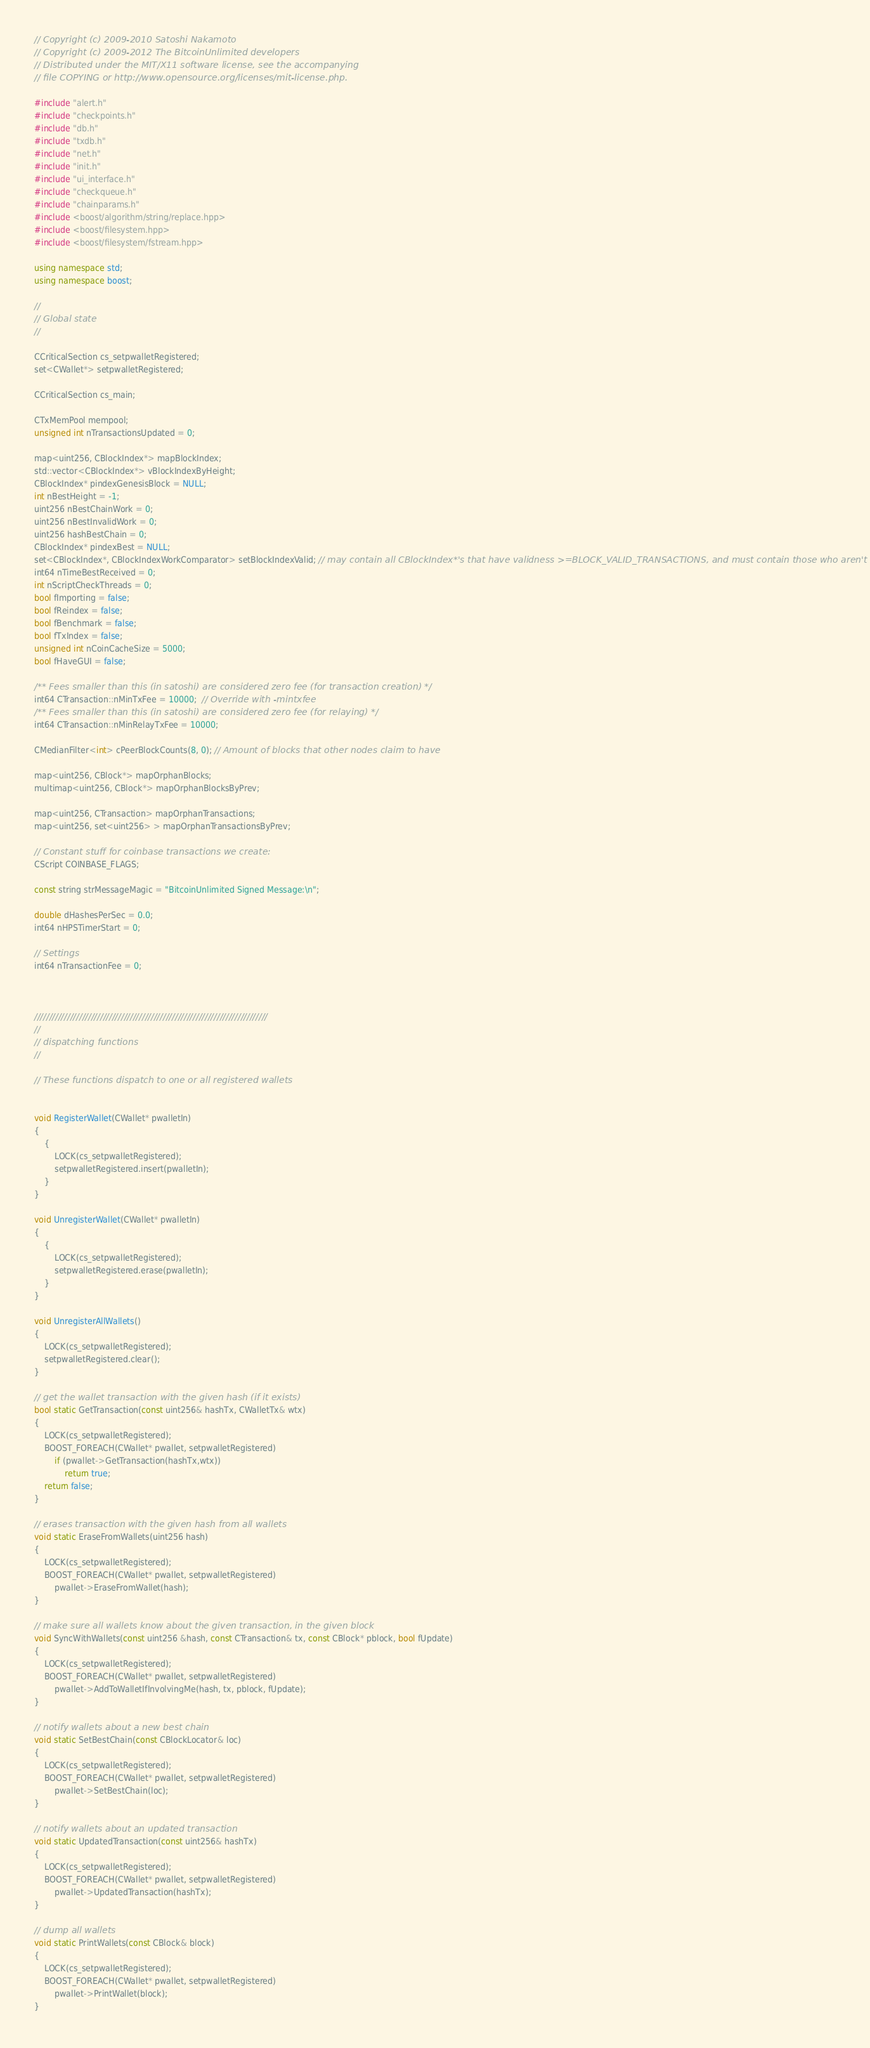Convert code to text. <code><loc_0><loc_0><loc_500><loc_500><_C++_>// Copyright (c) 2009-2010 Satoshi Nakamoto
// Copyright (c) 2009-2012 The BitcoinUnlimited developers
// Distributed under the MIT/X11 software license, see the accompanying
// file COPYING or http://www.opensource.org/licenses/mit-license.php.

#include "alert.h"
#include "checkpoints.h"
#include "db.h"
#include "txdb.h"
#include "net.h"
#include "init.h"
#include "ui_interface.h"
#include "checkqueue.h"
#include "chainparams.h"
#include <boost/algorithm/string/replace.hpp>
#include <boost/filesystem.hpp>
#include <boost/filesystem/fstream.hpp>

using namespace std;
using namespace boost;

//
// Global state
//

CCriticalSection cs_setpwalletRegistered;
set<CWallet*> setpwalletRegistered;

CCriticalSection cs_main;

CTxMemPool mempool;
unsigned int nTransactionsUpdated = 0;

map<uint256, CBlockIndex*> mapBlockIndex;
std::vector<CBlockIndex*> vBlockIndexByHeight;
CBlockIndex* pindexGenesisBlock = NULL;
int nBestHeight = -1;
uint256 nBestChainWork = 0;
uint256 nBestInvalidWork = 0;
uint256 hashBestChain = 0;
CBlockIndex* pindexBest = NULL;
set<CBlockIndex*, CBlockIndexWorkComparator> setBlockIndexValid; // may contain all CBlockIndex*'s that have validness >=BLOCK_VALID_TRANSACTIONS, and must contain those who aren't failed
int64 nTimeBestReceived = 0;
int nScriptCheckThreads = 0;
bool fImporting = false;
bool fReindex = false;
bool fBenchmark = false;
bool fTxIndex = false;
unsigned int nCoinCacheSize = 5000;
bool fHaveGUI = false;

/** Fees smaller than this (in satoshi) are considered zero fee (for transaction creation) */
int64 CTransaction::nMinTxFee = 10000;  // Override with -mintxfee
/** Fees smaller than this (in satoshi) are considered zero fee (for relaying) */
int64 CTransaction::nMinRelayTxFee = 10000;

CMedianFilter<int> cPeerBlockCounts(8, 0); // Amount of blocks that other nodes claim to have

map<uint256, CBlock*> mapOrphanBlocks;
multimap<uint256, CBlock*> mapOrphanBlocksByPrev;

map<uint256, CTransaction> mapOrphanTransactions;
map<uint256, set<uint256> > mapOrphanTransactionsByPrev;

// Constant stuff for coinbase transactions we create:
CScript COINBASE_FLAGS;

const string strMessageMagic = "BitcoinUnlimited Signed Message:\n";

double dHashesPerSec = 0.0;
int64 nHPSTimerStart = 0;

// Settings
int64 nTransactionFee = 0;



//////////////////////////////////////////////////////////////////////////////
//
// dispatching functions
//

// These functions dispatch to one or all registered wallets


void RegisterWallet(CWallet* pwalletIn)
{
    {
        LOCK(cs_setpwalletRegistered);
        setpwalletRegistered.insert(pwalletIn);
    }
}

void UnregisterWallet(CWallet* pwalletIn)
{
    {
        LOCK(cs_setpwalletRegistered);
        setpwalletRegistered.erase(pwalletIn);
    }
}

void UnregisterAllWallets()
{
    LOCK(cs_setpwalletRegistered);
    setpwalletRegistered.clear();
}

// get the wallet transaction with the given hash (if it exists)
bool static GetTransaction(const uint256& hashTx, CWalletTx& wtx)
{
    LOCK(cs_setpwalletRegistered);
    BOOST_FOREACH(CWallet* pwallet, setpwalletRegistered)
        if (pwallet->GetTransaction(hashTx,wtx))
            return true;
    return false;
}

// erases transaction with the given hash from all wallets
void static EraseFromWallets(uint256 hash)
{
    LOCK(cs_setpwalletRegistered);
    BOOST_FOREACH(CWallet* pwallet, setpwalletRegistered)
        pwallet->EraseFromWallet(hash);
}

// make sure all wallets know about the given transaction, in the given block
void SyncWithWallets(const uint256 &hash, const CTransaction& tx, const CBlock* pblock, bool fUpdate)
{
    LOCK(cs_setpwalletRegistered);
    BOOST_FOREACH(CWallet* pwallet, setpwalletRegistered)
        pwallet->AddToWalletIfInvolvingMe(hash, tx, pblock, fUpdate);
}

// notify wallets about a new best chain
void static SetBestChain(const CBlockLocator& loc)
{
    LOCK(cs_setpwalletRegistered);
    BOOST_FOREACH(CWallet* pwallet, setpwalletRegistered)
        pwallet->SetBestChain(loc);
}

// notify wallets about an updated transaction
void static UpdatedTransaction(const uint256& hashTx)
{
    LOCK(cs_setpwalletRegistered);
    BOOST_FOREACH(CWallet* pwallet, setpwalletRegistered)
        pwallet->UpdatedTransaction(hashTx);
}

// dump all wallets
void static PrintWallets(const CBlock& block)
{
    LOCK(cs_setpwalletRegistered);
    BOOST_FOREACH(CWallet* pwallet, setpwalletRegistered)
        pwallet->PrintWallet(block);
}
</code> 